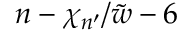Convert formula to latex. <formula><loc_0><loc_0><loc_500><loc_500>n - \chi _ { n ^ { \prime } } / \tilde { w } - 6</formula> 